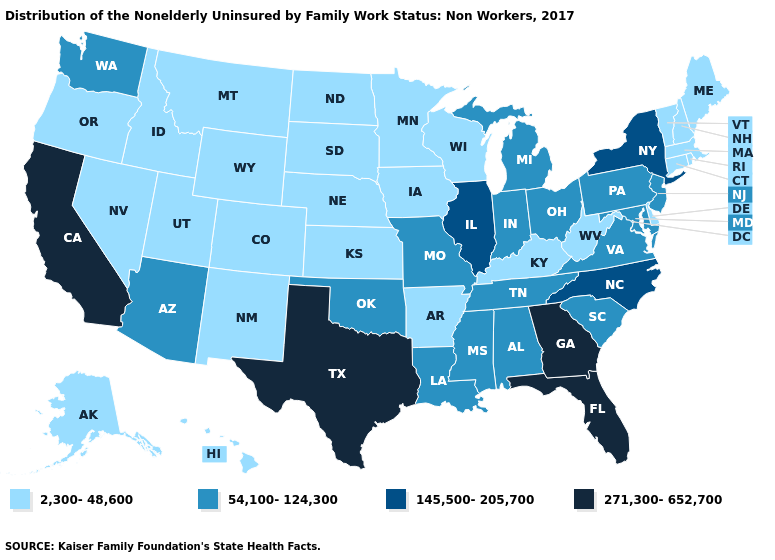What is the value of Tennessee?
Concise answer only. 54,100-124,300. What is the value of Iowa?
Write a very short answer. 2,300-48,600. What is the lowest value in the Northeast?
Write a very short answer. 2,300-48,600. What is the value of California?
Be succinct. 271,300-652,700. Which states hav the highest value in the MidWest?
Short answer required. Illinois. Does Oregon have the lowest value in the USA?
Answer briefly. Yes. What is the value of Mississippi?
Keep it brief. 54,100-124,300. What is the lowest value in the Northeast?
Answer briefly. 2,300-48,600. What is the lowest value in the MidWest?
Quick response, please. 2,300-48,600. Among the states that border New York , does Connecticut have the highest value?
Answer briefly. No. Does Michigan have the lowest value in the MidWest?
Quick response, please. No. How many symbols are there in the legend?
Answer briefly. 4. Does Kentucky have a lower value than Alabama?
Answer briefly. Yes. What is the value of Ohio?
Answer briefly. 54,100-124,300. 